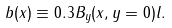<formula> <loc_0><loc_0><loc_500><loc_500>b ( x ) \equiv 0 . 3 B _ { y } ( x , y = 0 ) l .</formula> 